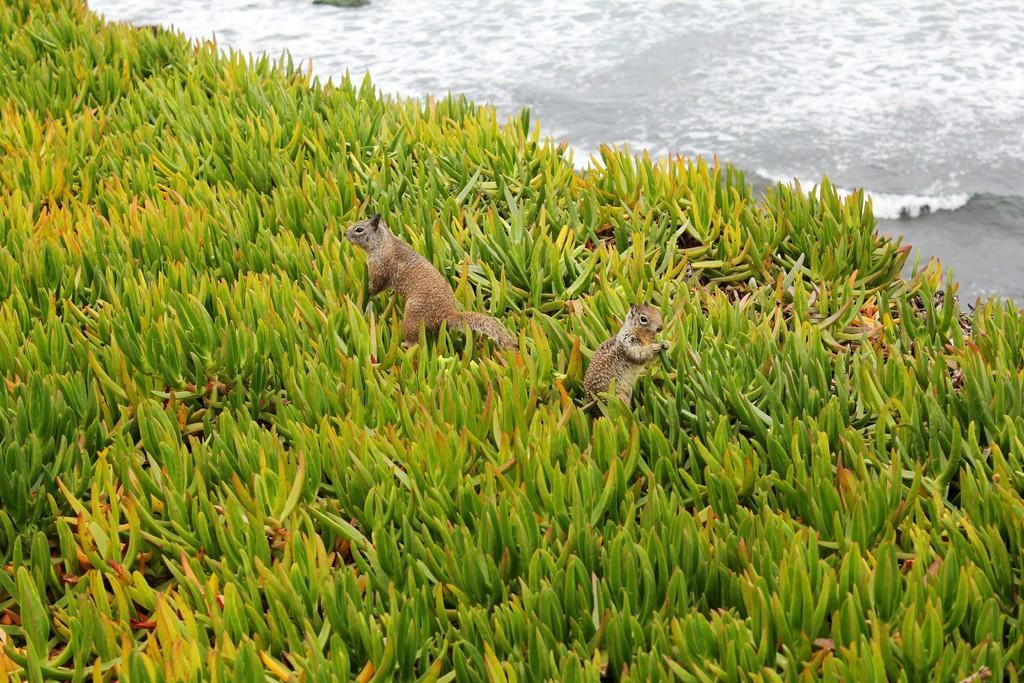In one or two sentences, can you explain what this image depicts? On the image there are leaves with two animals in it. At the top of the image there is water. 